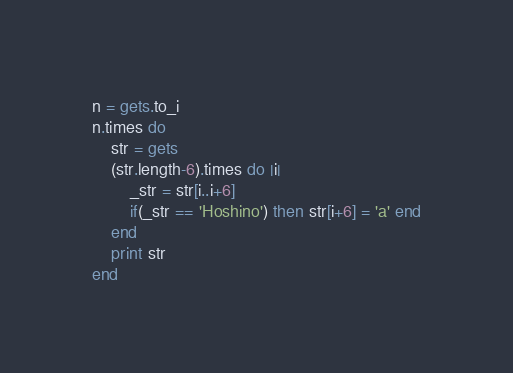Convert code to text. <code><loc_0><loc_0><loc_500><loc_500><_Ruby_>n = gets.to_i
n.times do
	str = gets
	(str.length-6).times do |i|
		_str = str[i..i+6]
		if(_str == 'Hoshino') then str[i+6] = 'a' end
	end
	print str
end</code> 